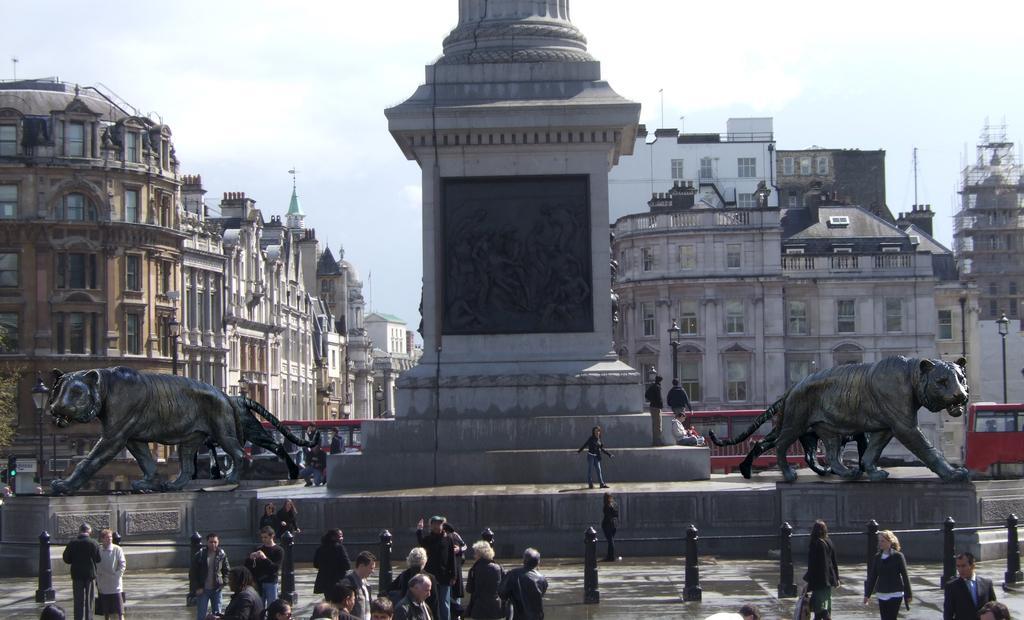How would you summarize this image in a sentence or two? In this image, we can see a pole in between sculptures. There is a crowd at the bottom of the image. There are buildings on the left and on the right side of the image. In the background of the image, there is a sky. 